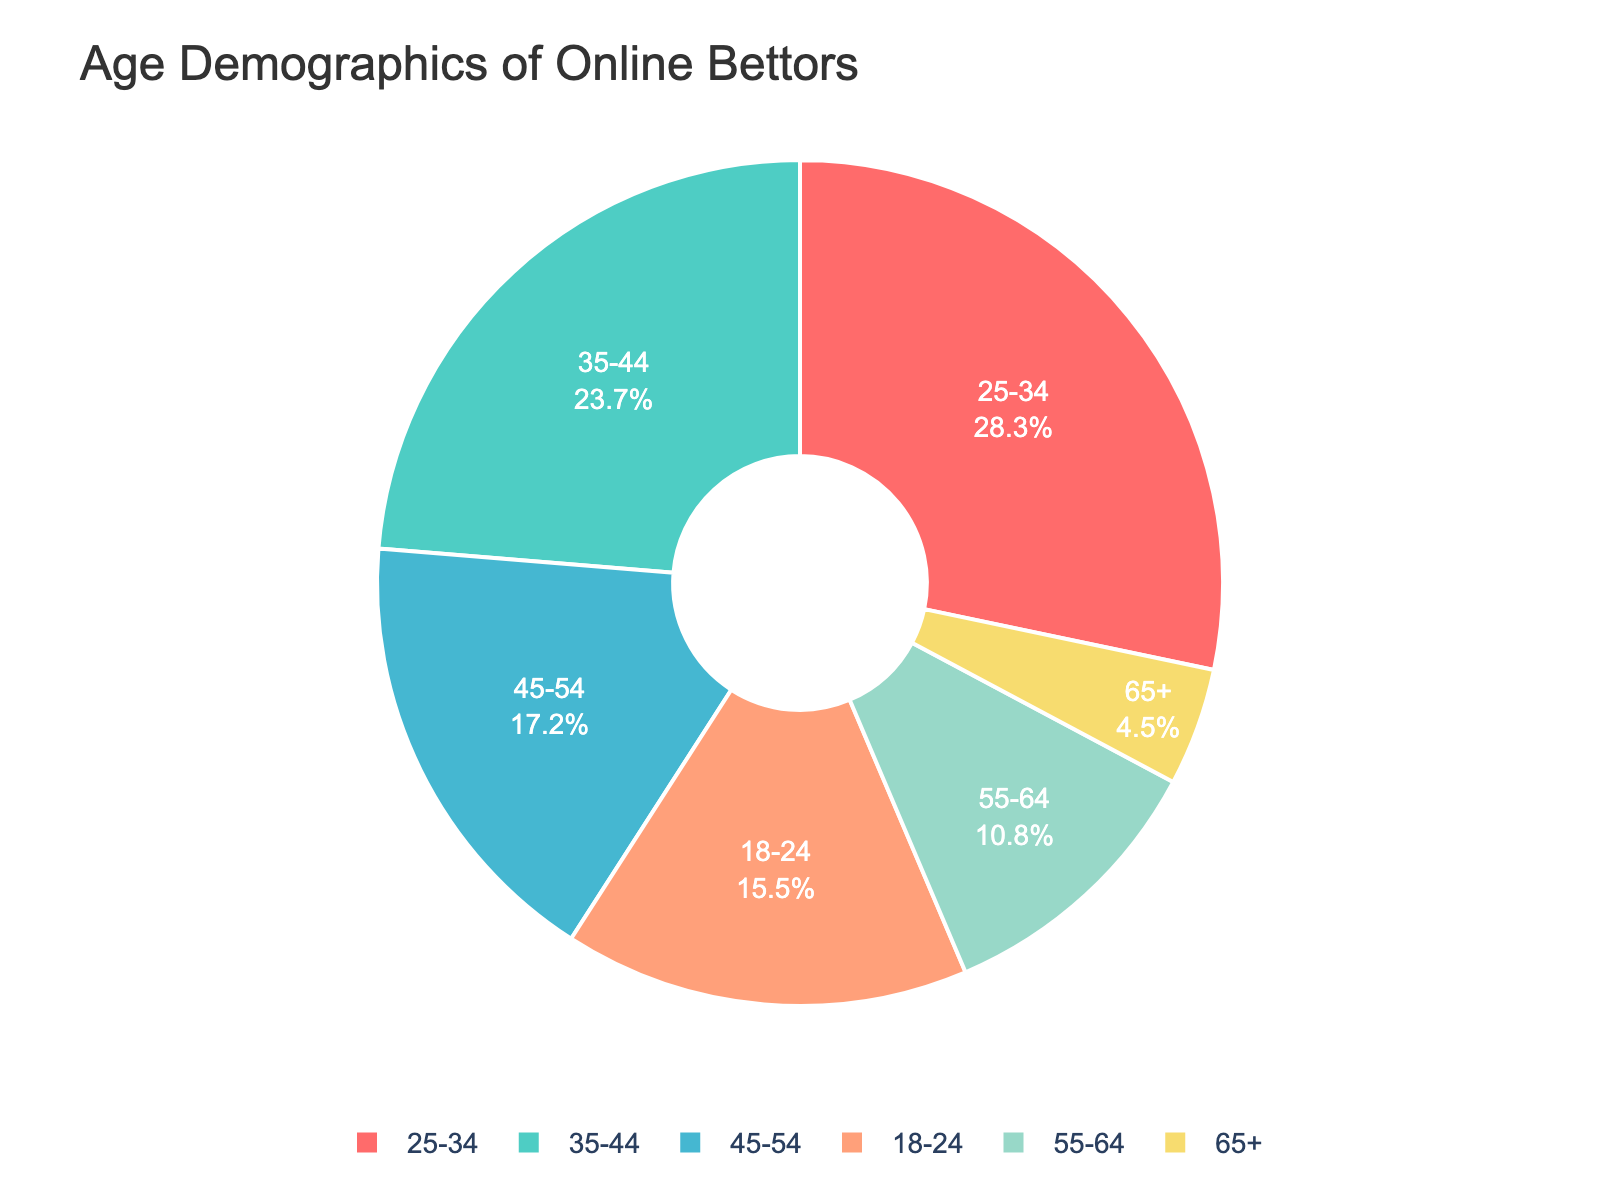what percentage of bettors are between 25 and 44 years old? Add the percentages of the age groups 25-34 (28.3%) and 35-44 (23.7%). So, the total is 28.3 + 23.7 = 52.0
Answer: 52.0 which age group has the largest proportion of bettors? The age group with the highest percentage in the pie chart is 25-34 with 28.3%
Answer: 25-34 how much greater is the proportion of bettors aged 35-44 compared to those aged 65+? Subtract the percentage of the 65+ group (4.5%) from the 35-44 group (23.7%): 23.7 - 4.5 = 19.2
Answer: 19.2 what is the combined percentage of bettors aged 55 and above? Add the percentages of the 55-64 (10.8%) and 65+ (4.5%) age groups: 10.8 + 4.5 = 15.3
Answer: 15.3 which group has a higher percentage, 18-24 or 45-54? Compare the percentages: 18-24 has 15.5%, and 45-54 has 17.2%, so 45-54 is higher
Answer: 45-54 what age group does the aqua color represent in the pie chart? By checking the custom color palette and the chart, the aqua color corresponds to the 25-34 age group
Answer: 25-34 if the percentages of the 35-44 and 45-54 age groups were combined, would it exceed the total of the 25-34 and 18-24 age groups? Add the percentages of the 35-44 (23.7%) and 45-54 (17.2%) groups: 23.7 + 17.2 = 40.9%; then add the percentages of the 25-34 (28.3%) and 18-24 (15.5%) groups: 28.3 + 15.5 = 43.8%. Since 43.8% is greater than 40.9%, the 25-34 and 18-24 groups' total is higher
Answer: No what percentage of bettors are younger than 35 years old? Add the percentages of the 18-24 (15.5%) and 25-34 (28.3%) groups: 15.5 + 28.3 = 43.8
Answer: 43.8 how does the percentage of bettors aged 55-64 compare to that of the 45-54 group? The percentage of the 45-54 group is 17.2%, while that of the 55-64 group is 10.8%. So, the 45-54 group has a higher percentage
Answer: 45-54 what's the percentage difference between the youngest and oldest age groups in the pie chart? Subtract the percentage of the 65+ group (4.5%) from the 18-24 group (15.5%): 15.5 - 4.5 = 11.0
Answer: 11.0 